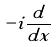Convert formula to latex. <formula><loc_0><loc_0><loc_500><loc_500>- i \frac { d } { d x }</formula> 